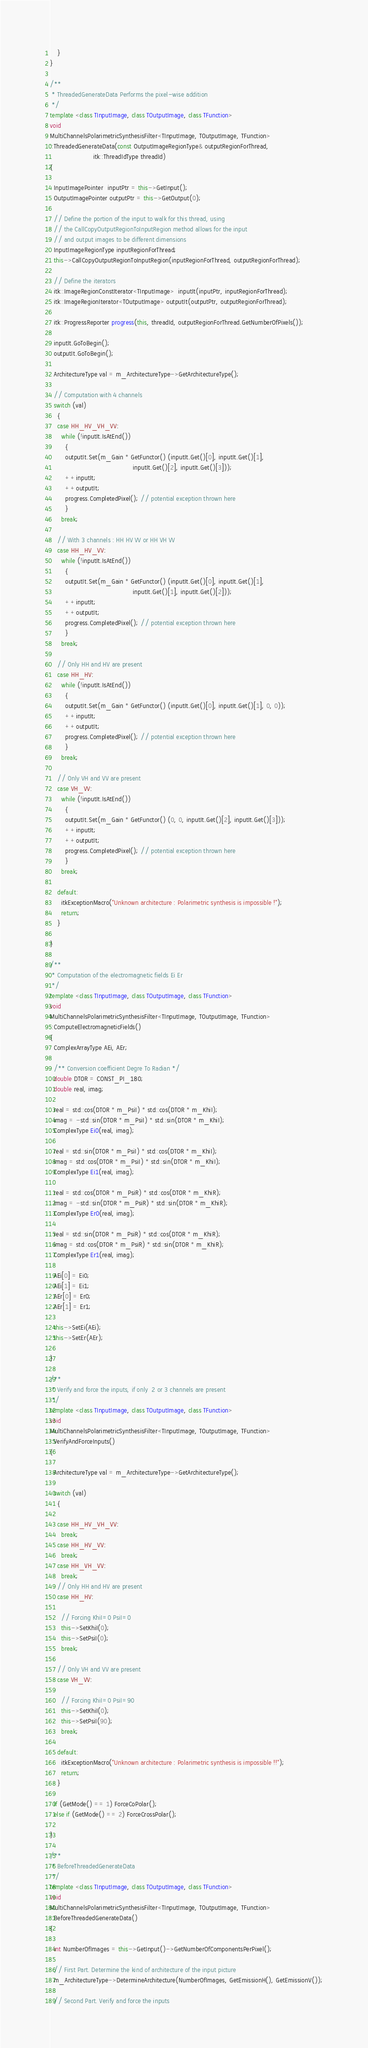<code> <loc_0><loc_0><loc_500><loc_500><_C++_>    }
}

/**
 * ThreadedGenerateData Performs the pixel-wise addition
 */
template <class TInputImage, class TOutputImage, class TFunction>
void
MultiChannelsPolarimetricSynthesisFilter<TInputImage, TOutputImage, TFunction>
::ThreadedGenerateData(const OutputImageRegionType& outputRegionForThread,
                       itk::ThreadIdType threadId)
{

  InputImagePointer  inputPtr = this->GetInput();
  OutputImagePointer outputPtr = this->GetOutput(0);

  // Define the portion of the input to walk for this thread, using
  // the CallCopyOutputRegionToInputRegion method allows for the input
  // and output images to be different dimensions
  InputImageRegionType inputRegionForThread;
  this->CallCopyOutputRegionToInputRegion(inputRegionForThread, outputRegionForThread);

  // Define the iterators
  itk::ImageRegionConstIterator<TInputImage>  inputIt(inputPtr, inputRegionForThread);
  itk::ImageRegionIterator<TOutputImage> outputIt(outputPtr, outputRegionForThread);

  itk::ProgressReporter progress(this, threadId, outputRegionForThread.GetNumberOfPixels());

  inputIt.GoToBegin();
  outputIt.GoToBegin();

  ArchitectureType val = m_ArchitectureType->GetArchitectureType();

  // Computation with 4 channels
  switch (val)
    {
    case HH_HV_VH_VV:
      while (!inputIt.IsAtEnd())
        {
        outputIt.Set(m_Gain * GetFunctor() (inputIt.Get()[0], inputIt.Get()[1],
                                            inputIt.Get()[2], inputIt.Get()[3]));
        ++inputIt;
        ++outputIt;
        progress.CompletedPixel(); // potential exception thrown here
        }
      break;

    // With 3 channels : HH HV VV or HH VH VV
    case HH_HV_VV:
      while (!inputIt.IsAtEnd())
        {
        outputIt.Set(m_Gain * GetFunctor() (inputIt.Get()[0], inputIt.Get()[1],
                                            inputIt.Get()[1], inputIt.Get()[2]));
        ++inputIt;
        ++outputIt;
        progress.CompletedPixel(); // potential exception thrown here
        }
      break;

    // Only HH and HV are present
    case HH_HV:
      while (!inputIt.IsAtEnd())
        {
        outputIt.Set(m_Gain * GetFunctor() (inputIt.Get()[0], inputIt.Get()[1], 0, 0));
        ++inputIt;
        ++outputIt;
        progress.CompletedPixel(); // potential exception thrown here
        }
      break;

    // Only VH and VV are present
    case VH_VV:
      while (!inputIt.IsAtEnd())
        {
        outputIt.Set(m_Gain * GetFunctor() (0, 0, inputIt.Get()[2], inputIt.Get()[3]));
        ++inputIt;
        ++outputIt;
        progress.CompletedPixel(); // potential exception thrown here
        }
      break;

    default:
      itkExceptionMacro("Unknown architecture : Polarimetric synthesis is impossible !");
      return;
    }

}

/**
 * Computation of the electromagnetic fields Ei Er
 */
template <class TInputImage, class TOutputImage, class TFunction>
void
MultiChannelsPolarimetricSynthesisFilter<TInputImage, TOutputImage, TFunction>
::ComputeElectromagneticFields()
{
  ComplexArrayType AEi, AEr;

  /** Conversion coefficient Degre To Radian */
  double DTOR = CONST_PI_180;
  double real, imag;

  real = std::cos(DTOR * m_PsiI) * std::cos(DTOR * m_KhiI);
  imag = -std::sin(DTOR * m_PsiI) * std::sin(DTOR * m_KhiI);
  ComplexType Ei0(real, imag);

  real = std::sin(DTOR * m_PsiI) * std::cos(DTOR * m_KhiI);
  imag = std::cos(DTOR * m_PsiI) * std::sin(DTOR * m_KhiI);
  ComplexType Ei1(real, imag);

  real = std::cos(DTOR * m_PsiR) * std::cos(DTOR * m_KhiR);
  imag = -std::sin(DTOR * m_PsiR) * std::sin(DTOR * m_KhiR);
  ComplexType Er0(real, imag);

  real = std::sin(DTOR * m_PsiR) * std::cos(DTOR * m_KhiR);
  imag = std::cos(DTOR * m_PsiR) * std::sin(DTOR * m_KhiR);
  ComplexType Er1(real, imag);

  AEi[0] = Ei0;
  AEi[1] = Ei1;
  AEr[0] = Er0;
  AEr[1] = Er1;

  this->SetEi(AEi);
  this->SetEr(AEr);

}

/**
 * Verify and force the inputs, if only  2 or 3 channels are present
 */
template <class TInputImage, class TOutputImage, class TFunction>
void
MultiChannelsPolarimetricSynthesisFilter<TInputImage, TOutputImage, TFunction>
::VerifyAndForceInputs()
{

  ArchitectureType val = m_ArchitectureType->GetArchitectureType();

  switch (val)
    {

    case HH_HV_VH_VV:
      break;
    case HH_HV_VV:
      break;
    case HH_VH_VV:
      break;
    // Only HH and HV are present
    case HH_HV:

      // Forcing KhiI=0 PsiI=0
      this->SetKhiI(0);
      this->SetPsiI(0);
      break;

    // Only VH and VV are present
    case VH_VV:

      // Forcing KhiI=0 PsiI=90
      this->SetKhiI(0);
      this->SetPsiI(90);
      break;

    default:
      itkExceptionMacro("Unknown architecture : Polarimetric synthesis is impossible !!");
      return;
    }

  if (GetMode() == 1) ForceCoPolar();
  else if (GetMode() == 2) ForceCrossPolar();

}

/**
 * BeforeThreadedGenerateData
 */
template <class TInputImage, class TOutputImage, class TFunction>
void
MultiChannelsPolarimetricSynthesisFilter<TInputImage, TOutputImage, TFunction>
::BeforeThreadedGenerateData()
{

  int NumberOfImages = this->GetInput()->GetNumberOfComponentsPerPixel();

  // First Part. Determine the kind of architecture of the input picture
  m_ArchitectureType->DetermineArchitecture(NumberOfImages, GetEmissionH(), GetEmissionV());

  // Second Part. Verify and force the inputs</code> 